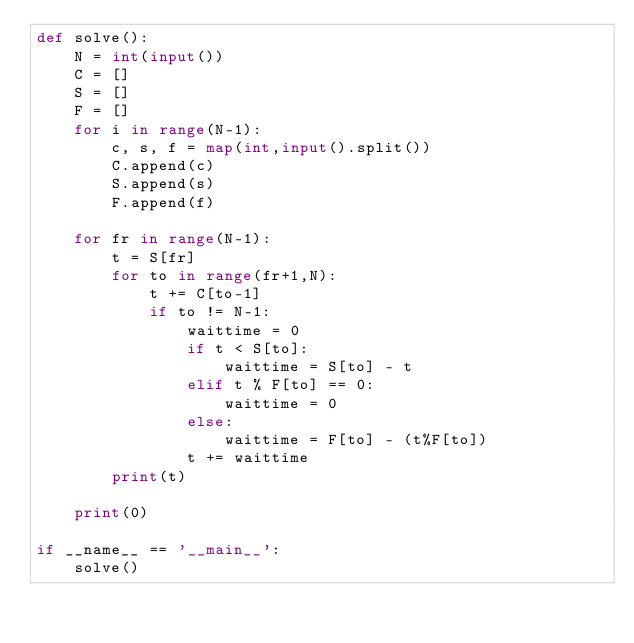Convert code to text. <code><loc_0><loc_0><loc_500><loc_500><_Python_>def solve():
    N = int(input())
    C = []
    S = []
    F = []
    for i in range(N-1):
        c, s, f = map(int,input().split())
        C.append(c)
        S.append(s)
        F.append(f)
    
    for fr in range(N-1):
        t = S[fr]
        for to in range(fr+1,N):
            t += C[to-1]
            if to != N-1:
                waittime = 0
                if t < S[to]:
                    waittime = S[to] - t
                elif t % F[to] == 0:
                    waittime = 0
                else:
                    waittime = F[to] - (t%F[to])
                t += waittime
        print(t)
            
    print(0)

if __name__ == '__main__':
    solve()</code> 